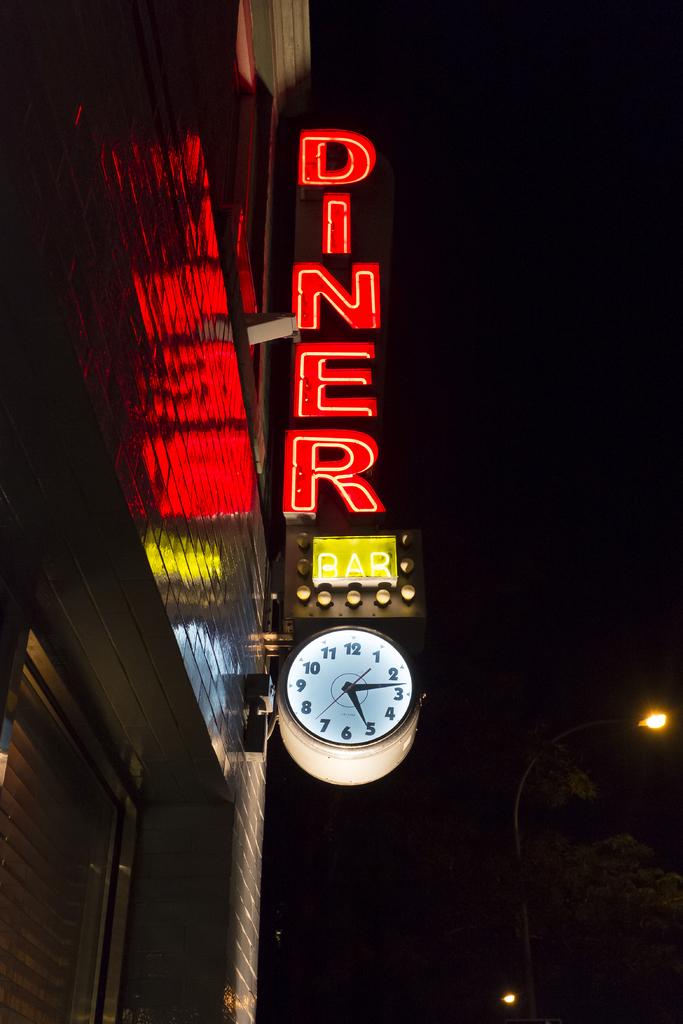What kind of restaurant is this?
Provide a succinct answer. Diner. 